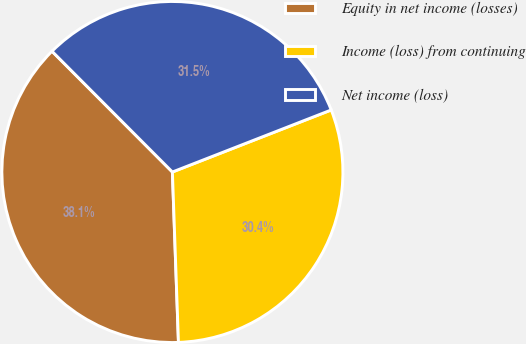Convert chart. <chart><loc_0><loc_0><loc_500><loc_500><pie_chart><fcel>Equity in net income (losses)<fcel>Income (loss) from continuing<fcel>Net income (loss)<nl><fcel>38.09%<fcel>30.36%<fcel>31.55%<nl></chart> 